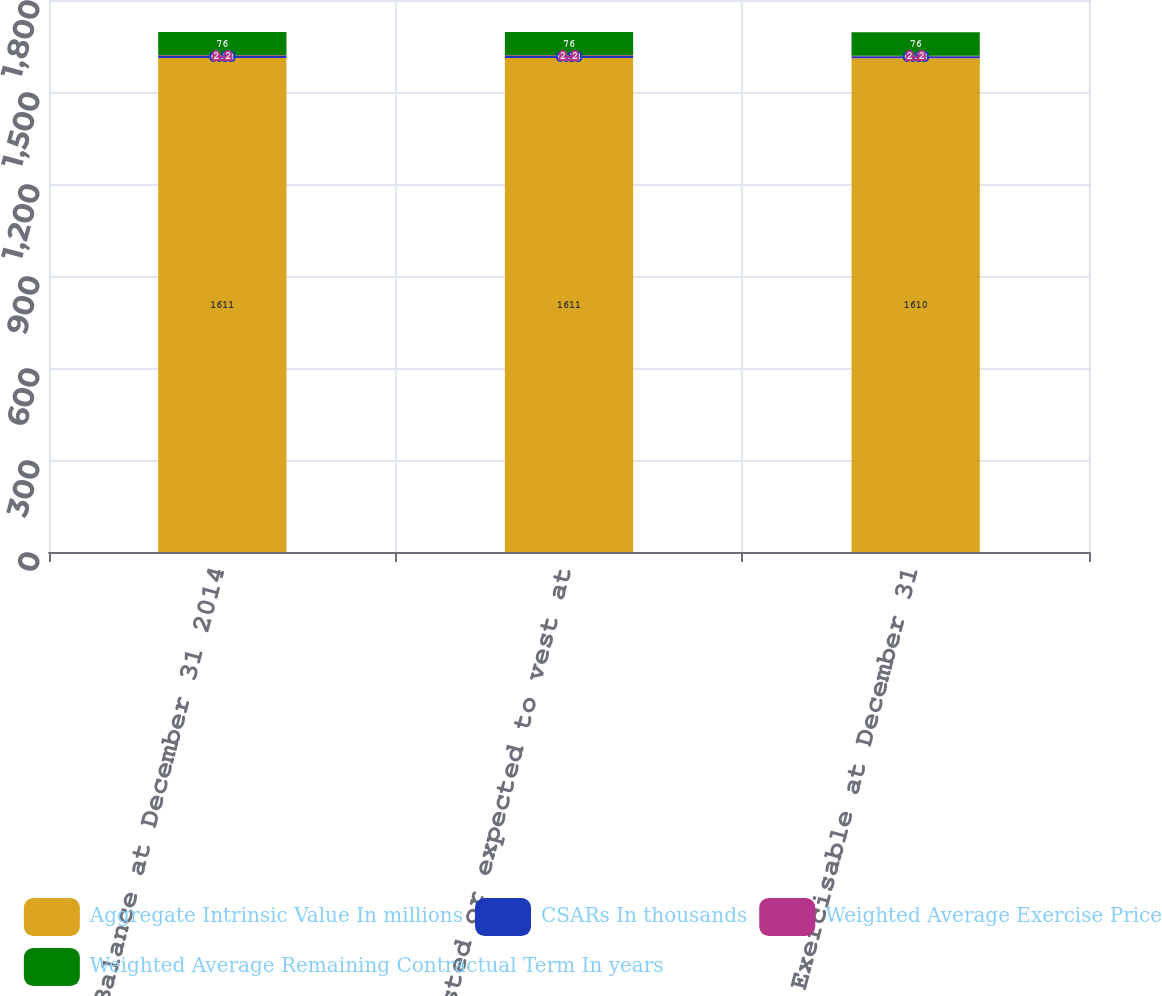<chart> <loc_0><loc_0><loc_500><loc_500><stacked_bar_chart><ecel><fcel>Balance at December 31 2014<fcel>Vested or expected to vest at<fcel>Exercisable at December 31<nl><fcel>Aggregate Intrinsic Value In millions<fcel>1611<fcel>1611<fcel>1610<nl><fcel>CSARs In thousands<fcel>6.33<fcel>6.33<fcel>6.33<nl><fcel>Weighted Average Exercise Price<fcel>2.2<fcel>2.2<fcel>2.2<nl><fcel>Weighted Average Remaining Contractual Term In years<fcel>76<fcel>76<fcel>76<nl></chart> 